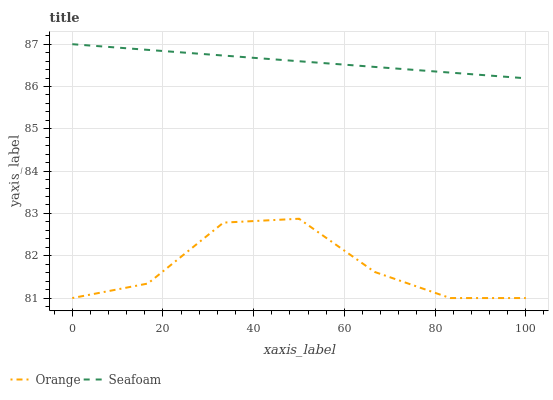Does Orange have the minimum area under the curve?
Answer yes or no. Yes. Does Seafoam have the maximum area under the curve?
Answer yes or no. Yes. Does Seafoam have the minimum area under the curve?
Answer yes or no. No. Is Seafoam the smoothest?
Answer yes or no. Yes. Is Orange the roughest?
Answer yes or no. Yes. Is Seafoam the roughest?
Answer yes or no. No. Does Orange have the lowest value?
Answer yes or no. Yes. Does Seafoam have the lowest value?
Answer yes or no. No. Does Seafoam have the highest value?
Answer yes or no. Yes. Is Orange less than Seafoam?
Answer yes or no. Yes. Is Seafoam greater than Orange?
Answer yes or no. Yes. Does Orange intersect Seafoam?
Answer yes or no. No. 